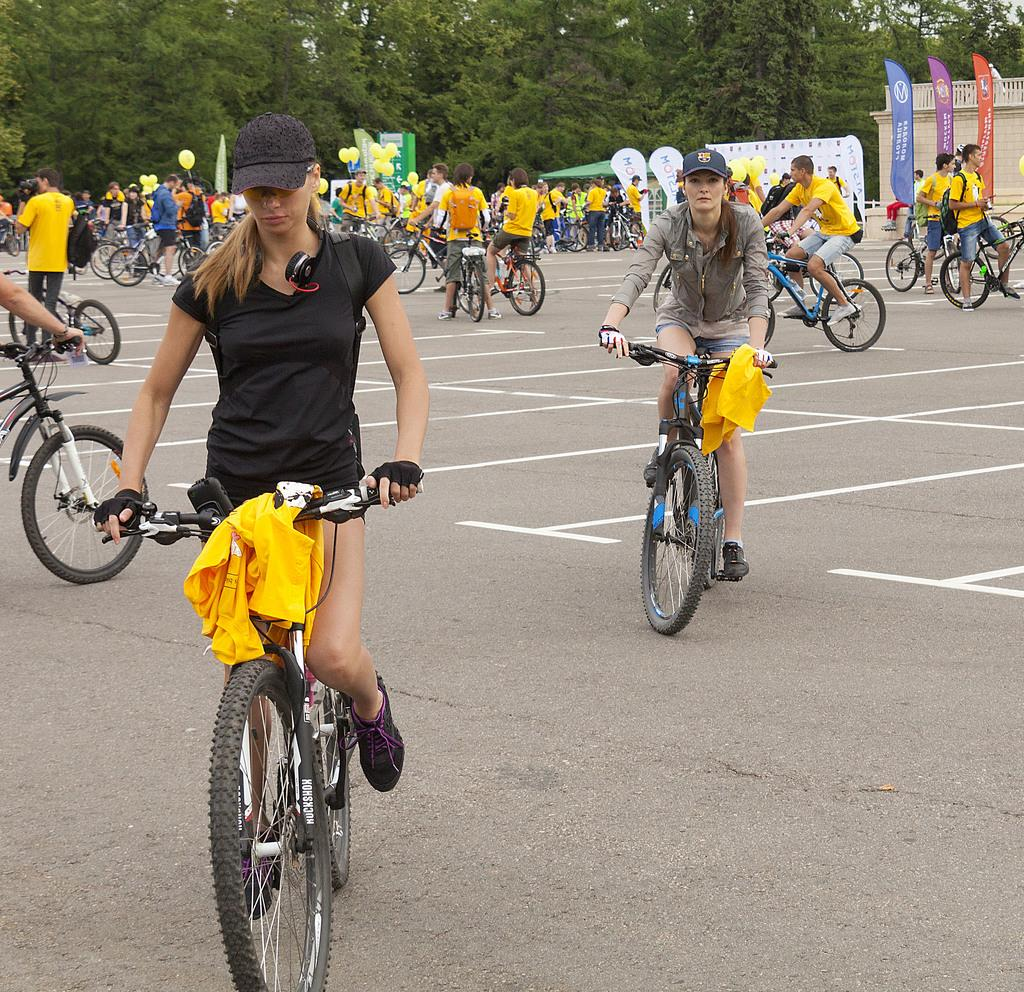How many people are in the image? There is a group of people in the image. What are the people in the image doing? The group of people are riding a bicycle. Where is the bicycle located? The bicycle is on the road. What can be seen in the background of the image? There are trees in the background of the image. What type of coat is the kitten wearing while riding the bicycle in the image? There is no kitten or coat present in the image; it features a group of people riding a bicycle on the road. How many steps are required for the group to reach the end of the road in the image? The image does not provide information about the number of steps or the distance to the end of the road, as it only shows the group riding a bicycle on the road. 